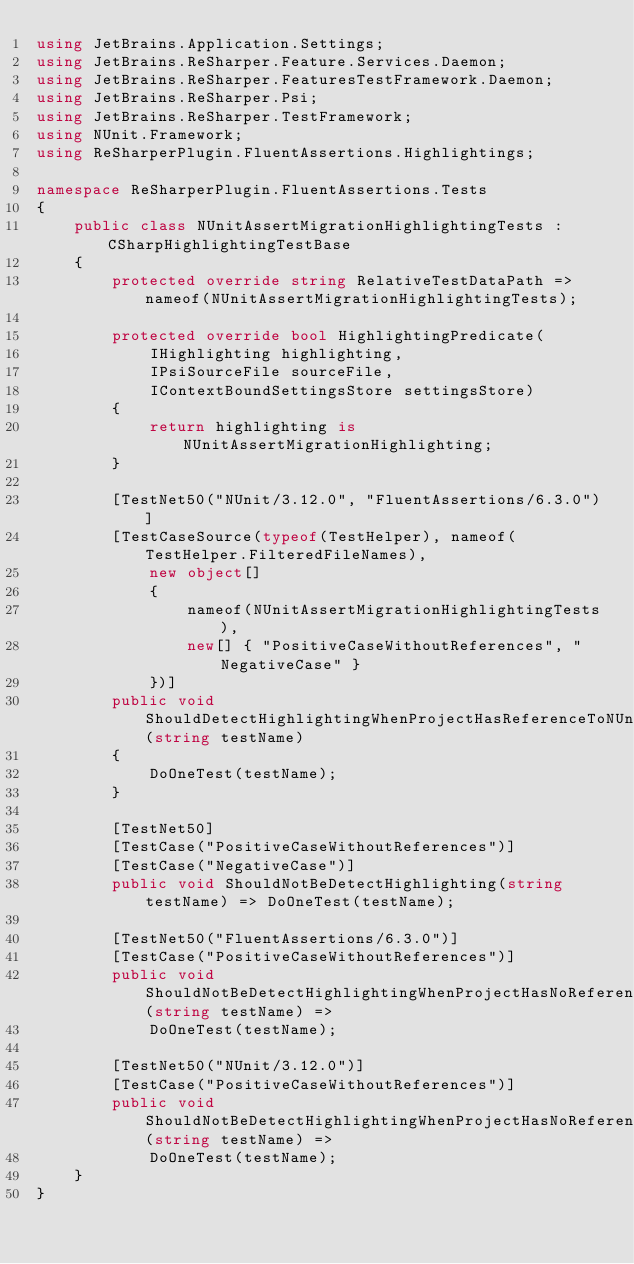Convert code to text. <code><loc_0><loc_0><loc_500><loc_500><_C#_>using JetBrains.Application.Settings;
using JetBrains.ReSharper.Feature.Services.Daemon;
using JetBrains.ReSharper.FeaturesTestFramework.Daemon;
using JetBrains.ReSharper.Psi;
using JetBrains.ReSharper.TestFramework;
using NUnit.Framework;
using ReSharperPlugin.FluentAssertions.Highlightings;

namespace ReSharperPlugin.FluentAssertions.Tests
{
    public class NUnitAssertMigrationHighlightingTests : CSharpHighlightingTestBase
    {
        protected override string RelativeTestDataPath => nameof(NUnitAssertMigrationHighlightingTests);

        protected override bool HighlightingPredicate(
            IHighlighting highlighting,
            IPsiSourceFile sourceFile,
            IContextBoundSettingsStore settingsStore)
        {
            return highlighting is NUnitAssertMigrationHighlighting;
        }

        [TestNet50("NUnit/3.12.0", "FluentAssertions/6.3.0")]
        [TestCaseSource(typeof(TestHelper), nameof(TestHelper.FilteredFileNames),
            new object[]
            {
                nameof(NUnitAssertMigrationHighlightingTests),
                new[] { "PositiveCaseWithoutReferences", "NegativeCase" }
            })]
        public void ShouldDetectHighlightingWhenProjectHasReferenceToNUnitAndFluentAssertions(string testName)
        {
            DoOneTest(testName);
        }

        [TestNet50]
        [TestCase("PositiveCaseWithoutReferences")]
        [TestCase("NegativeCase")]
        public void ShouldNotBeDetectHighlighting(string testName) => DoOneTest(testName);

        [TestNet50("FluentAssertions/6.3.0")]
        [TestCase("PositiveCaseWithoutReferences")]
        public void ShouldNotBeDetectHighlightingWhenProjectHasNoReferenceToNUnit(string testName) =>
            DoOneTest(testName);

        [TestNet50("NUnit/3.12.0")]
        [TestCase("PositiveCaseWithoutReferences")]
        public void ShouldNotBeDetectHighlightingWhenProjectHasNoReferenceToFluentAssertions(string testName) =>
            DoOneTest(testName);
    }
}</code> 